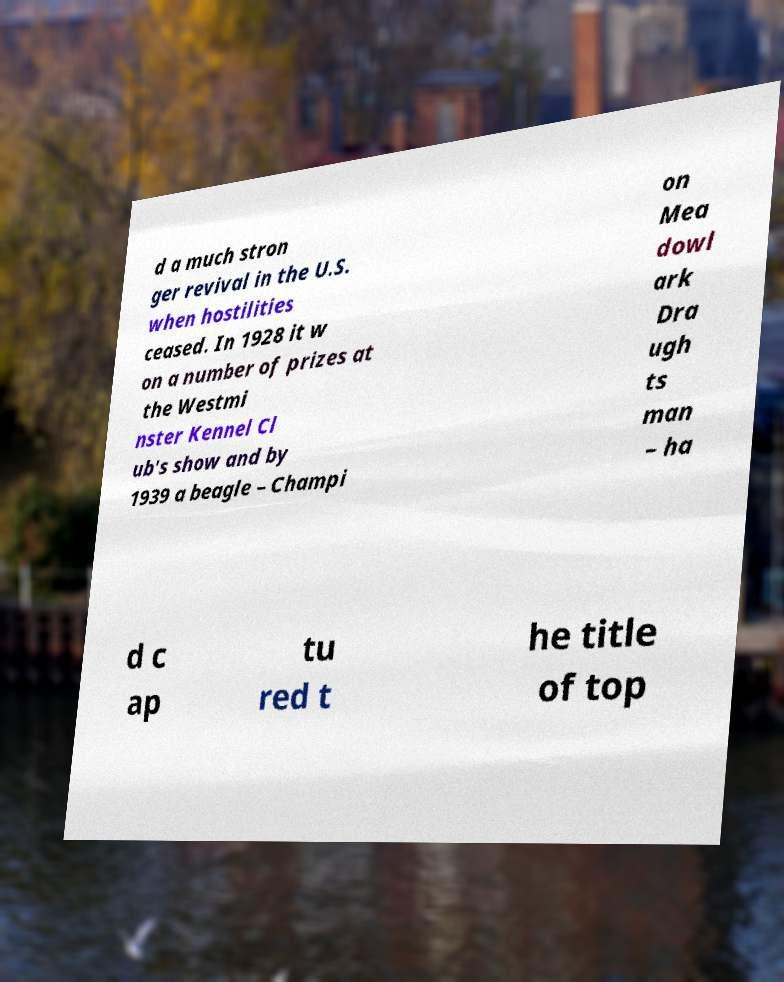For documentation purposes, I need the text within this image transcribed. Could you provide that? d a much stron ger revival in the U.S. when hostilities ceased. In 1928 it w on a number of prizes at the Westmi nster Kennel Cl ub's show and by 1939 a beagle – Champi on Mea dowl ark Dra ugh ts man – ha d c ap tu red t he title of top 